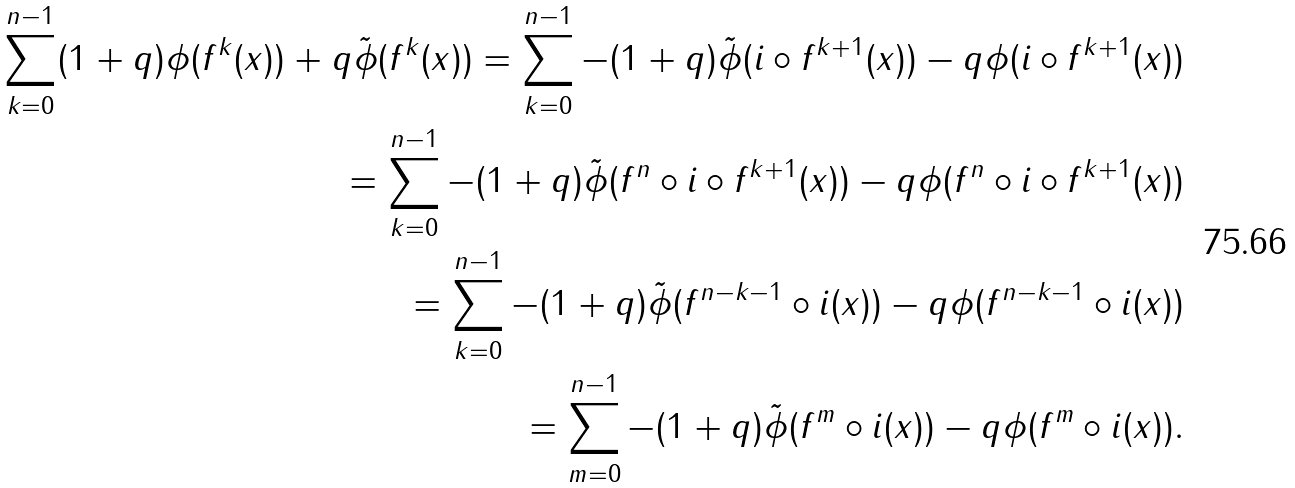Convert formula to latex. <formula><loc_0><loc_0><loc_500><loc_500>\sum _ { k = 0 } ^ { n - 1 } ( 1 + q ) \phi ( f ^ { k } ( x ) ) + q \tilde { \phi } ( f ^ { k } ( x ) ) = \sum _ { k = 0 } ^ { n - 1 } - ( 1 + q ) \tilde { \phi } ( i \circ f ^ { k + 1 } ( x ) ) - q \phi ( i \circ f ^ { k + 1 } ( x ) ) \\ = \sum _ { k = 0 } ^ { n - 1 } - ( 1 + q ) \tilde { \phi } ( f ^ { n } \circ i \circ f ^ { k + 1 } ( x ) ) - q \phi ( f ^ { n } \circ i \circ f ^ { k + 1 } ( x ) ) \\ = \sum _ { k = 0 } ^ { n - 1 } - ( 1 + q ) \tilde { \phi } ( f ^ { n - k - 1 } \circ i ( x ) ) - q \phi ( f ^ { n - k - 1 } \circ i ( x ) ) \\ = \sum _ { m = 0 } ^ { n - 1 } - ( 1 + q ) \tilde { \phi } ( f ^ { m } \circ i ( x ) ) - q \phi ( f ^ { m } \circ i ( x ) ) .</formula> 